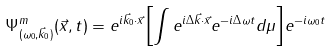Convert formula to latex. <formula><loc_0><loc_0><loc_500><loc_500>\Psi ^ { m } _ { ( \omega _ { 0 } , \vec { k } _ { 0 } ) } ( \vec { x } , t ) = e ^ { i \vec { k } _ { 0 } { \cdot } \vec { x } } { \left [ \int e ^ { i \Delta \vec { k } { \cdot } \vec { x } } e ^ { - i \Delta \omega t } d \mu \right ] } e ^ { - i \omega _ { 0 } t }</formula> 